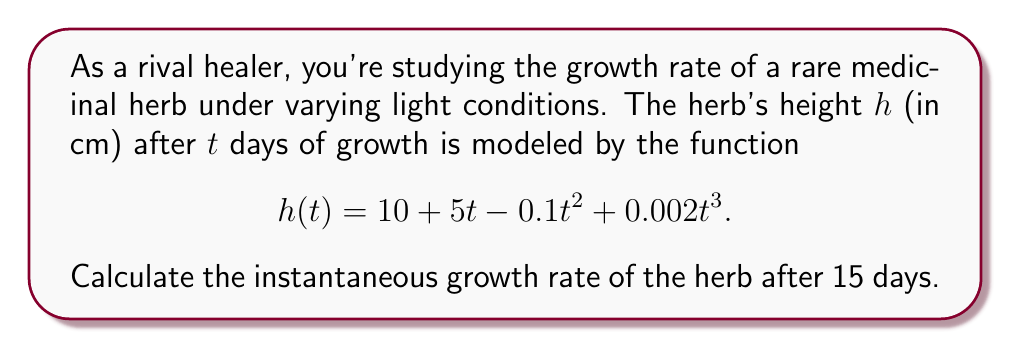Give your solution to this math problem. To find the instantaneous growth rate after 15 days, we need to calculate the derivative of the height function $h(t)$ and evaluate it at $t=15$. Let's break this down step-by-step:

1) First, let's find the derivative of $h(t)$:
   
   $h(t) = 10 + 5t - 0.1t^2 + 0.002t^3$
   
   $h'(t) = 5 - 0.2t + 0.006t^2$

2) Now we need to evaluate $h'(15)$:
   
   $h'(15) = 5 - 0.2(15) + 0.006(15)^2$
   
3) Let's calculate each term:
   
   $5 = 5$
   $-0.2(15) = -3$
   $0.006(15)^2 = 0.006(225) = 1.35$

4) Sum up the terms:
   
   $h'(15) = 5 - 3 + 1.35 = 3.35$

The instantaneous growth rate is the value of the derivative at the given point. Therefore, after 15 days, the herb is growing at a rate of 3.35 cm per day.
Answer: $3.35$ cm/day 